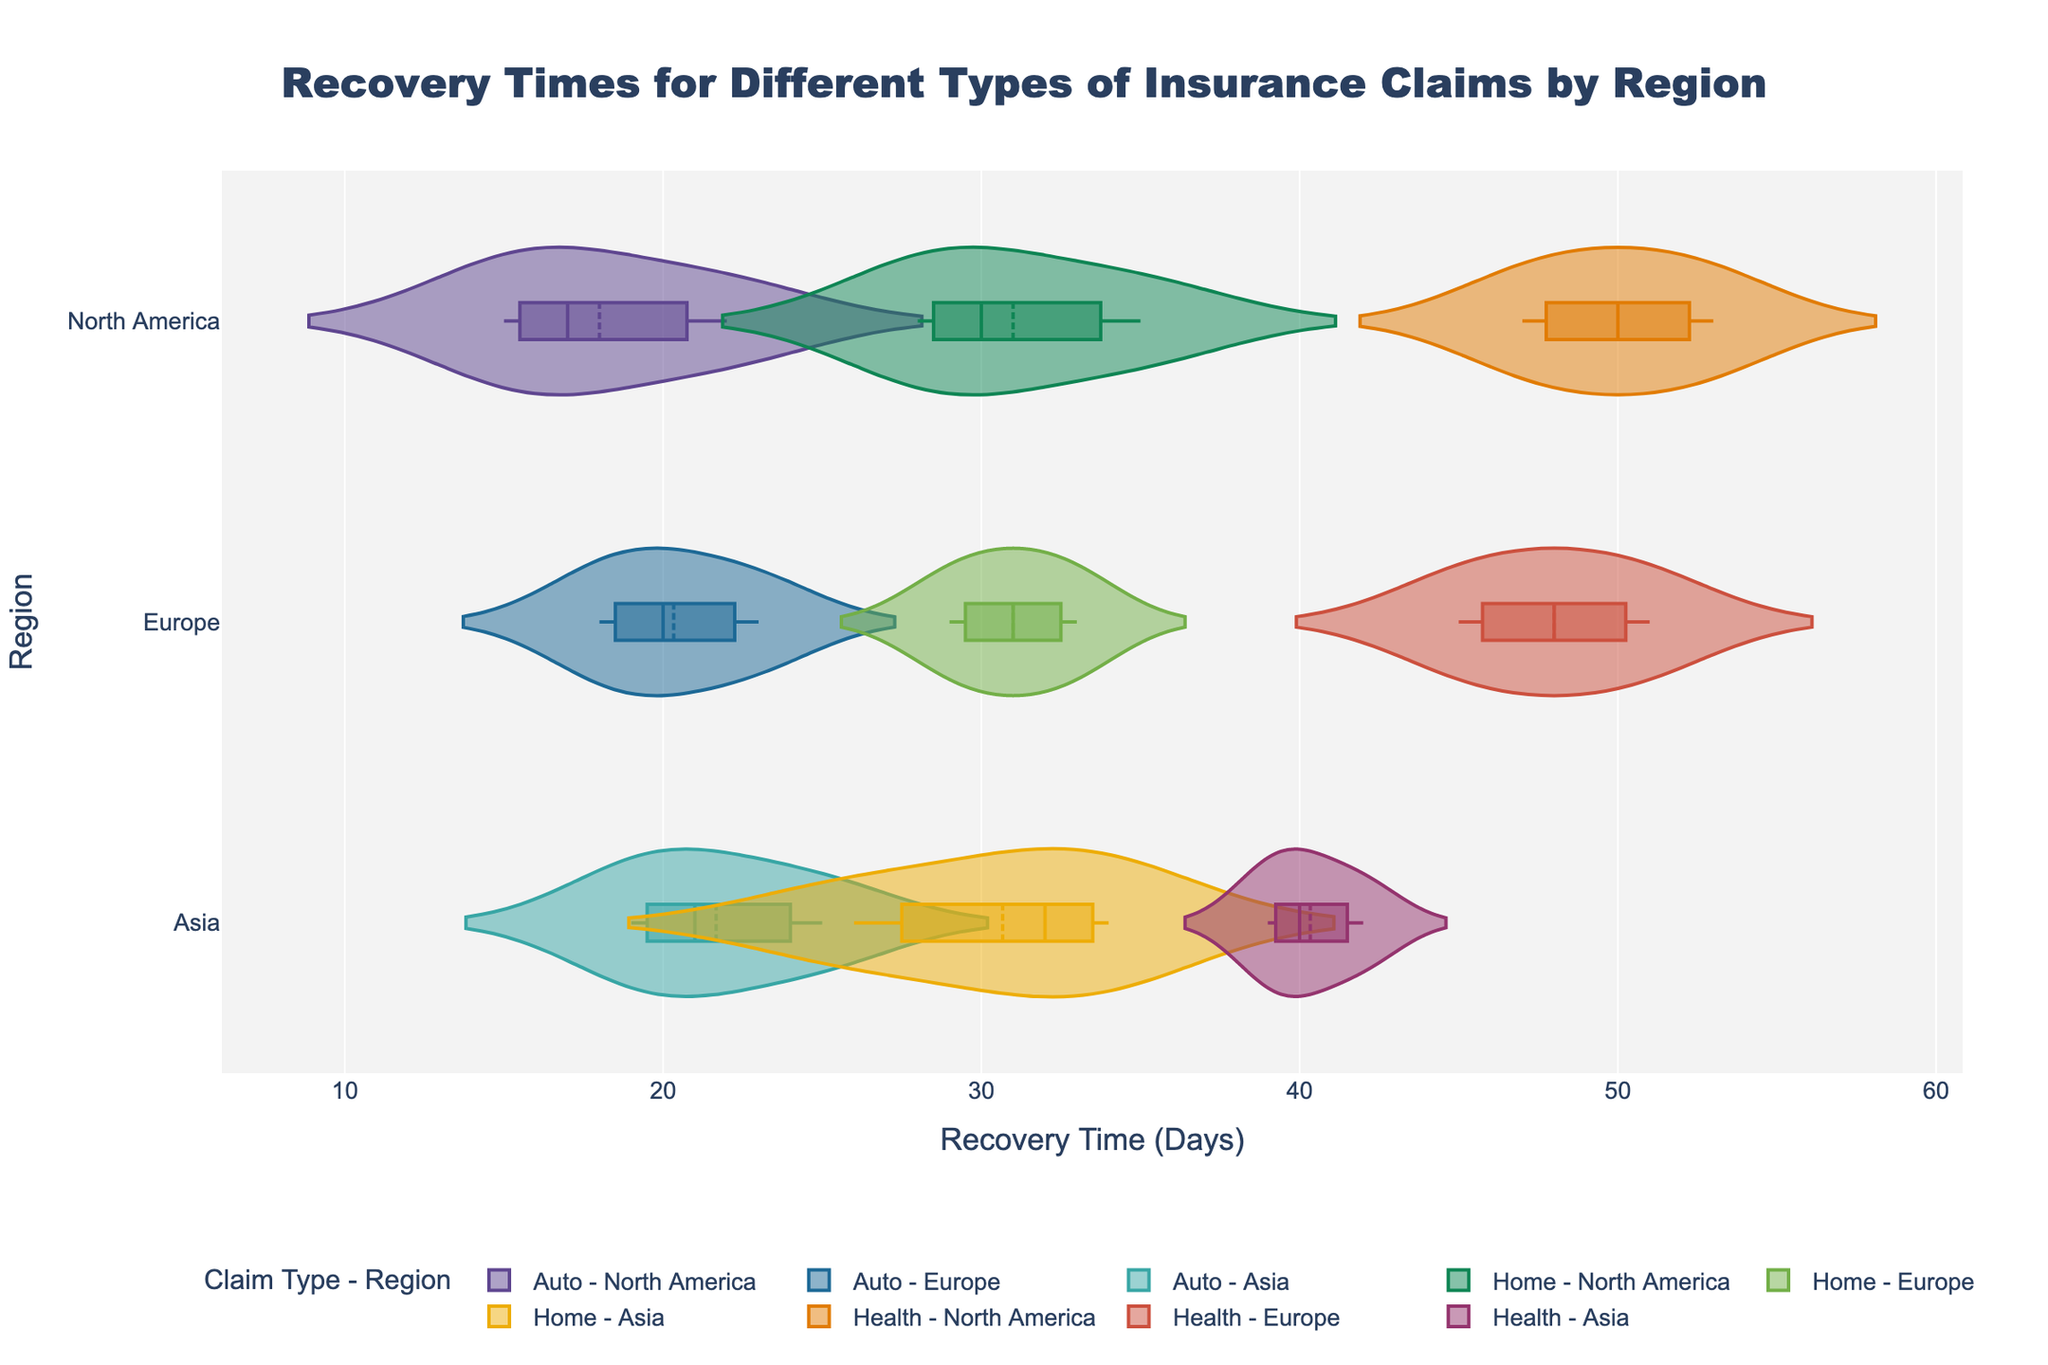What is the title of the chart? The title is located at the top center of the chart. The large, bold text reads "Recovery Times for Different Types of Insurance Claims by Region".
Answer: Recovery Times for Different Types of Insurance Claims by Region What is the average recovery time for Home insurance claims in Asia? Referring to the horizontal violins for the "Home - Asia" group, the data points for recovery times are 26, 32, and 34 days. Add these values together (26 + 32 + 34 = 92) and divide by the number of data points (3).
Answer: 30.67 days Which region has the longest average recovery time for Health insurance claims? Comparing the mean lines in the violin charts for Health insurance claims across different regions (North America, Europe, and Asia), the region with the highest average recovery time has the longest mean line.
Answer: North America Which claim type in Europe shows the highest variability in recovery times? To determine variability, look at the spread and width of the violin plots in Europe. The widest and most spread-out violin plot in Europe indicates the highest variability.
Answer: Auto What is the recovery time range for Auto insurance claims in Asia? The range is determined by the minimum and maximum points in the violin plot's area. For Auto insurance claims in Asia, the minimum time is 19 days, and the maximum time is 25 days.
Answer: 19 to 25 days Are Home insurance claims resolved faster in North America or Europe on average? Compare the mean lines of the Home insurance claims violin plots for North America and Europe. The mean line closer to the left (shorter axis) represents the faster resolution.
Answer: North America Which insurance claim type has the smallest average recovery time in Asia? Compare the mean lines across Auto, Home, and Health insurance claim types in Asia. The shortest mean line indicates the smallest average recovery time.
Answer: Auto What does the box in each violin plot represent? The box within each violin plot signifies the interquartile range (IQR), which represents the middle 50% of the data points.
Answer: Interquartile range How many different claim types are compared in the chart? By inspecting the legend, each unique color represents a different claim type. The chart compares three claim types: Auto, Home, and Health.
Answer: 3 Which insurance claim type has the greatest recovery time spread in North America? By examining the width and spreading of the violin plots for North America, identify the one with the widest spread from minimum to maximum recovery times.
Answer: Health 